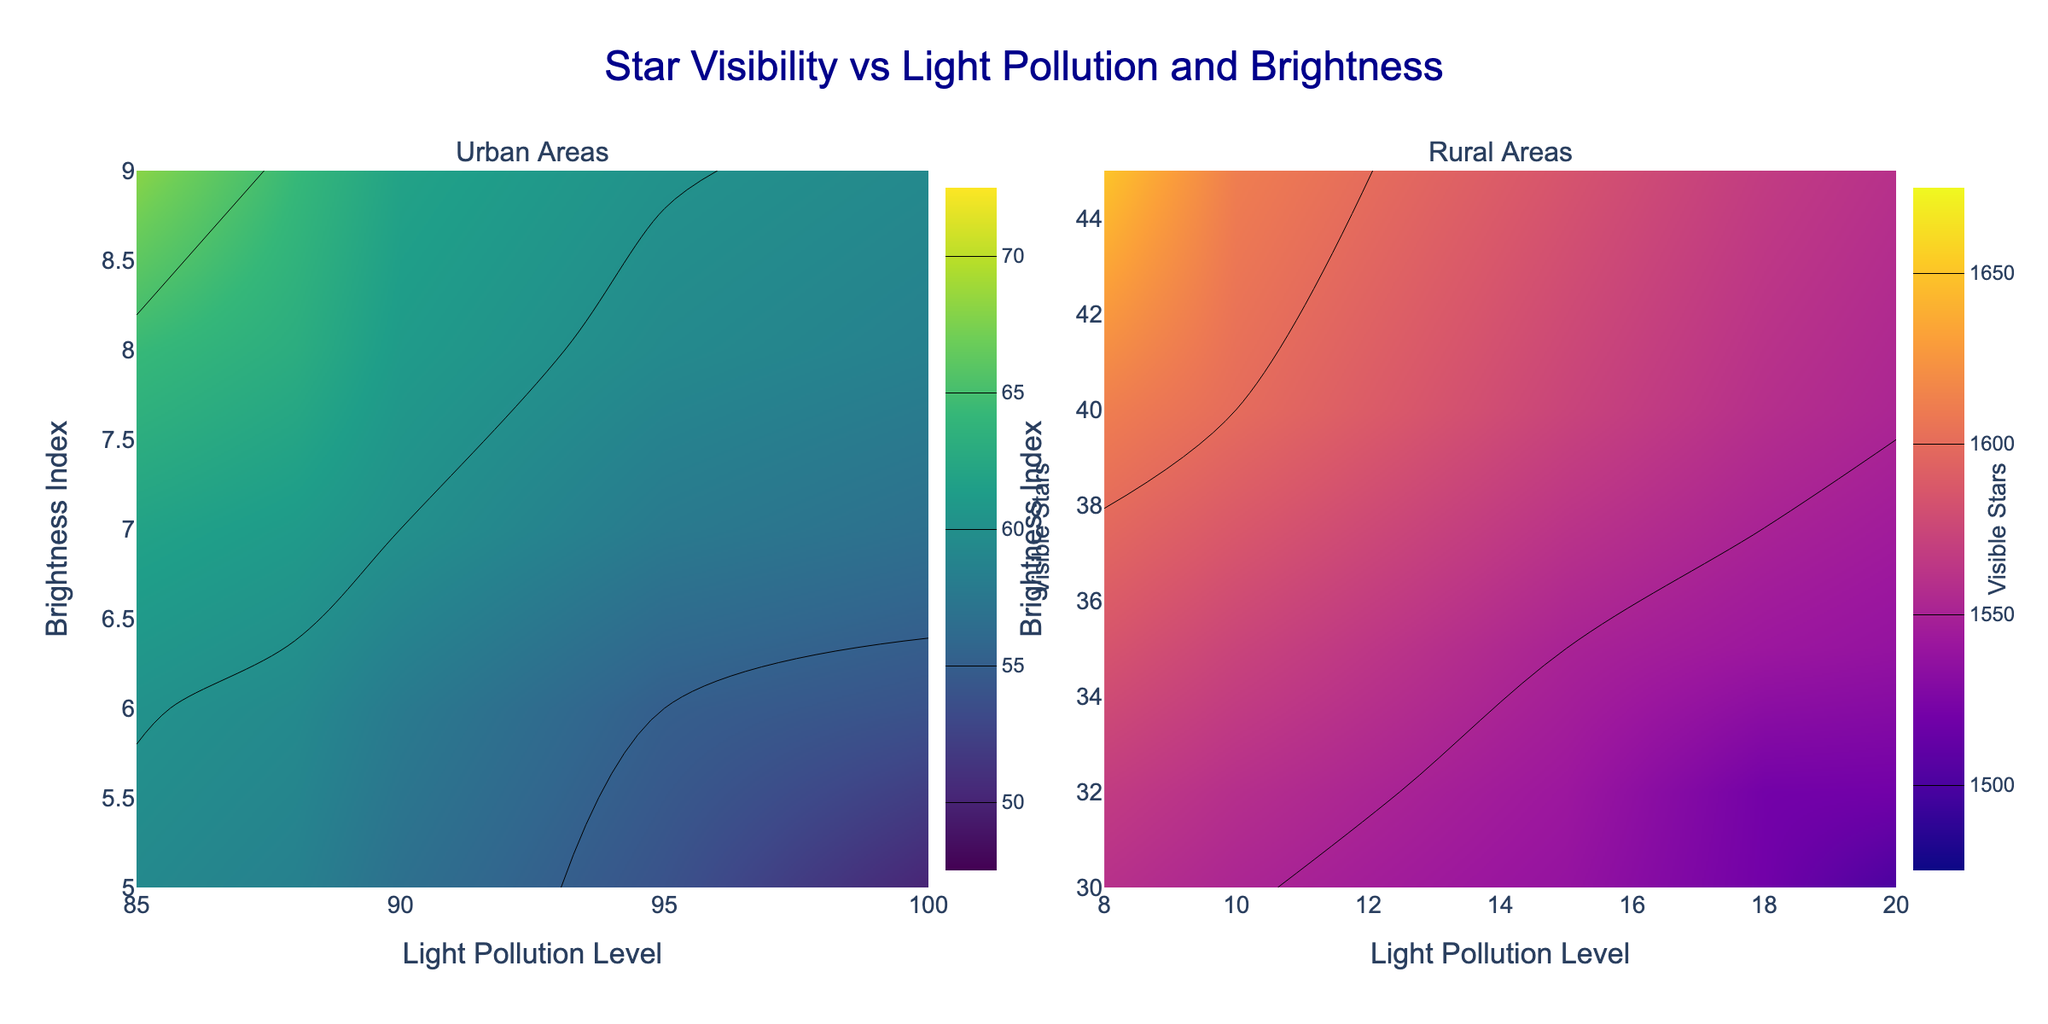How many subplots are there in the figure? The figure consists of two subplots, one for urban areas and one for rural areas, as indicated by the subplot titles "Urban Areas" and "Rural Areas."
Answer: 2 What's the title of the figure? The title of the figure, located at the top, is "Star Visibility vs Light Pollution and Brightness."
Answer: Star Visibility vs Light Pollution and Brightness What is the range of light pollution levels in urban areas displayed in the left subplot? The light pollution levels for urban areas range from about 85 to 100, as shown on the x-axis of the left subplot.
Answer: About 85 to 100 In the urban subplot, what is the highest value of the visible stars count? In the urban subplot, the highest value of the visible stars count contour is 68, as indicated by the color bar range on the left-hand side.
Answer: 68 What is the gradient or pattern of visible stars with increasing light pollution in urban areas? In the urban subplot, as the light pollution level increases, the visible stars count generally decreases, as shown by the contours indicating fewer stars at higher pollution levels.
Answer: Decreases Compare the range of visible stars count between urban and rural areas. Which ranges are higher? In the urban subplot, the visible stars count ranges from 50 to 68, while in the rural subplot, it ranges from 1500 to 1650. This shows that rural areas have a significantly higher range of visible stars.
Answer: Rural areas Where do brightness index values start for rural areas in the right subplot? In the rural subplot, the brightness index values start from around 30 and go up to about 45, as indicated on the y-axis.
Answer: Around 30 What does the color difference between the left and right subplots signify? The left subplot uses a 'Viridis' color scale for urban areas, and the right subplot uses a 'Plasma' color scale for rural areas, reflecting different ranges of visible stars counts suitable for respective star visibility.
Answer: Different visible stars counts Which subplot shows a higher correlation between brightness index and visible stars count? The rural subplot shows a higher correlation, with a more noticeable increase in visible stars count as brightness index increases, compared to the urban subplot where the change is less distinct.
Answer: Rural subplot Considering both subplots, where is the best location for stargazing? Based on the high visible stars count in the rural subplot, rural areas are the best locations for stargazing.
Answer: Rural areas 